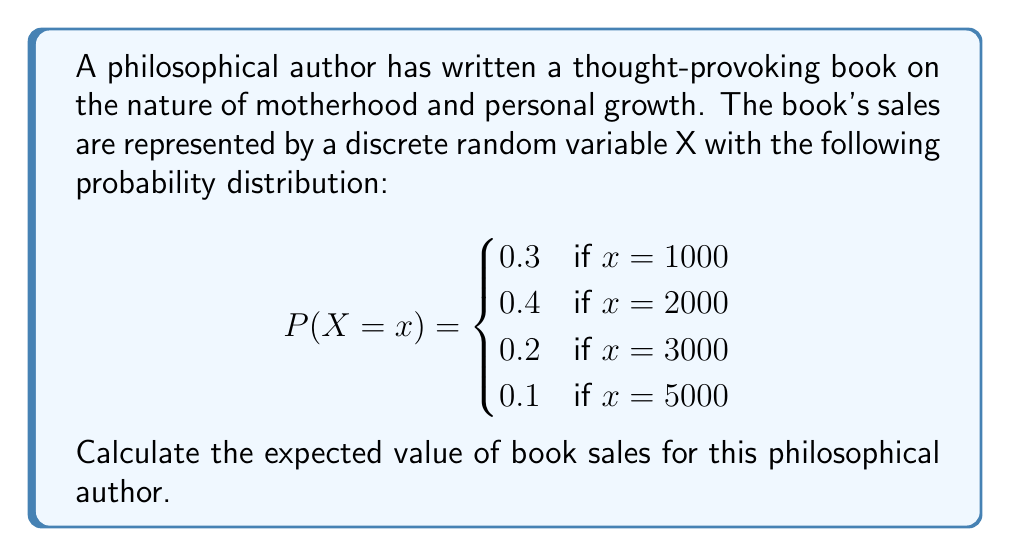Can you solve this math problem? To calculate the expected value of a discrete random variable, we use the formula:

$$E(X) = \sum_{x} x \cdot P(X = x)$$

Where $x$ represents each possible value of the random variable, and $P(X = x)$ is the probability of that value occurring.

Let's calculate each term:

1. For $x = 1000$: $1000 \cdot 0.3 = 300$
2. For $x = 2000$: $2000 \cdot 0.4 = 800$
3. For $x = 3000$: $3000 \cdot 0.2 = 600$
4. For $x = 5000$: $5000 \cdot 0.1 = 500$

Now, we sum all these terms:

$$E(X) = 300 + 800 + 600 + 500 = 2200$$

Therefore, the expected value of book sales for this philosophical author is 2200 copies.
Answer: $E(X) = 2200$ copies 